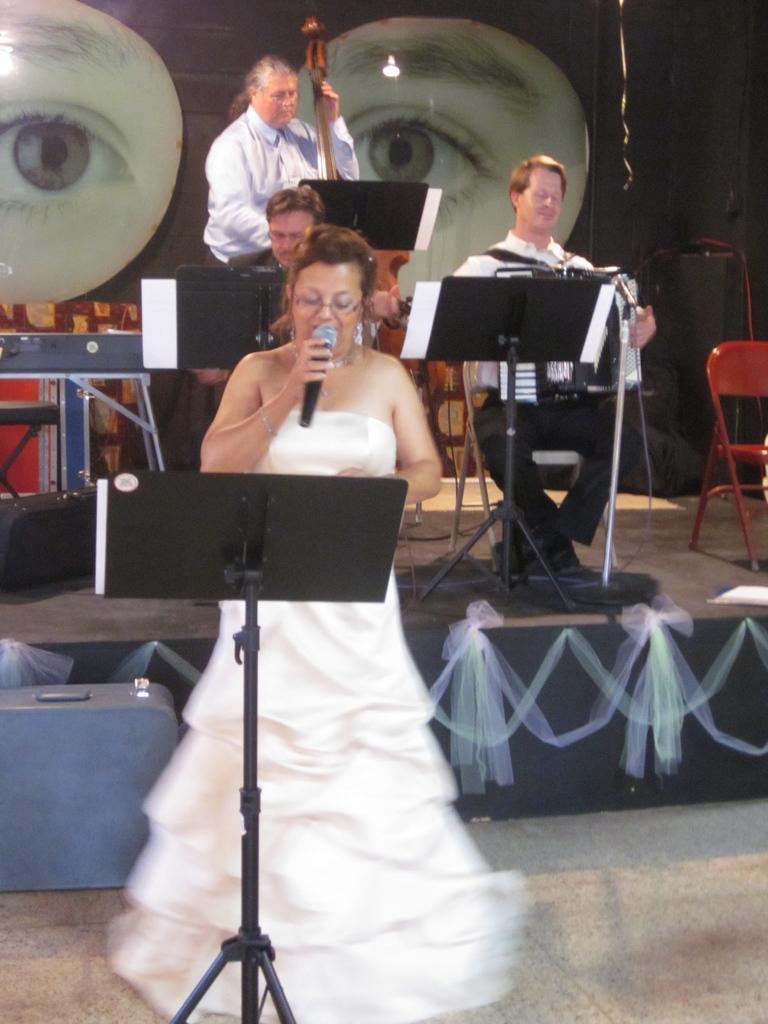Can you describe this image briefly? There is a woman wearing white dress is standing and holding a mic in her hand and singing in front of it and there is a stand in front of her and there are few persons playing music behind her. 